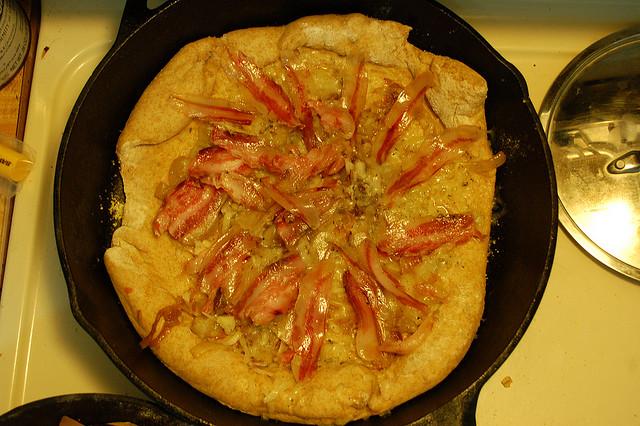Is it sliced?
Write a very short answer. No. Is this a pizza?
Quick response, please. Yes. What toppings are on the pizza?
Keep it brief. Bacon. 